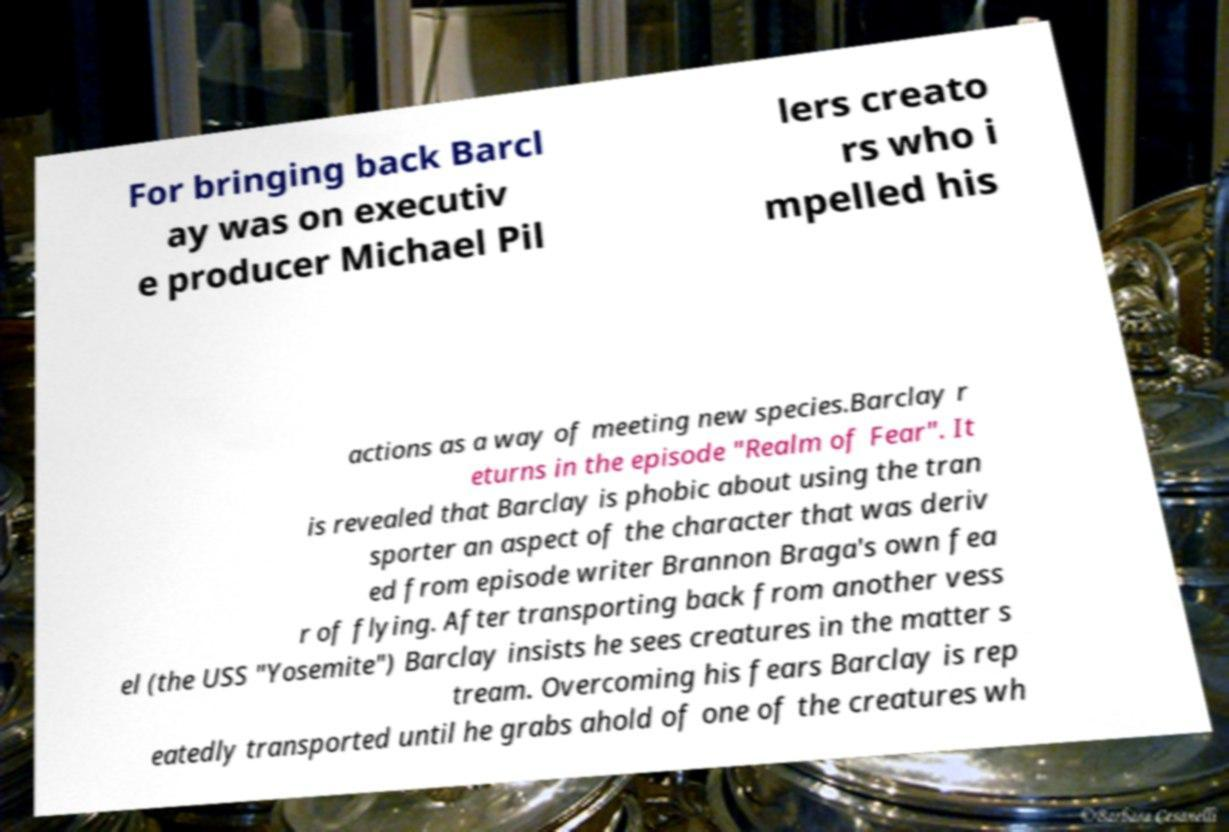There's text embedded in this image that I need extracted. Can you transcribe it verbatim? For bringing back Barcl ay was on executiv e producer Michael Pil lers creato rs who i mpelled his actions as a way of meeting new species.Barclay r eturns in the episode "Realm of Fear". It is revealed that Barclay is phobic about using the tran sporter an aspect of the character that was deriv ed from episode writer Brannon Braga's own fea r of flying. After transporting back from another vess el (the USS "Yosemite") Barclay insists he sees creatures in the matter s tream. Overcoming his fears Barclay is rep eatedly transported until he grabs ahold of one of the creatures wh 